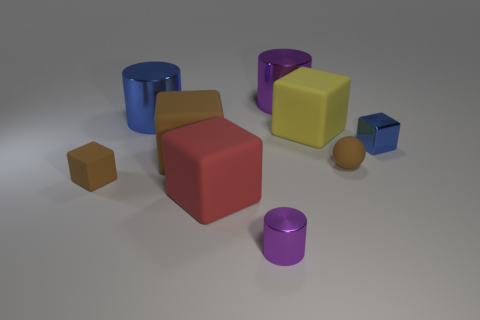Subtract all yellow blocks. How many blocks are left? 4 Subtract all yellow cubes. How many cubes are left? 4 Subtract all green cubes. Subtract all brown cylinders. How many cubes are left? 5 Add 1 small blue shiny blocks. How many objects exist? 10 Subtract all cylinders. How many objects are left? 6 Add 4 cubes. How many cubes exist? 9 Subtract 0 cyan spheres. How many objects are left? 9 Subtract all small yellow blocks. Subtract all small brown balls. How many objects are left? 8 Add 3 matte things. How many matte things are left? 8 